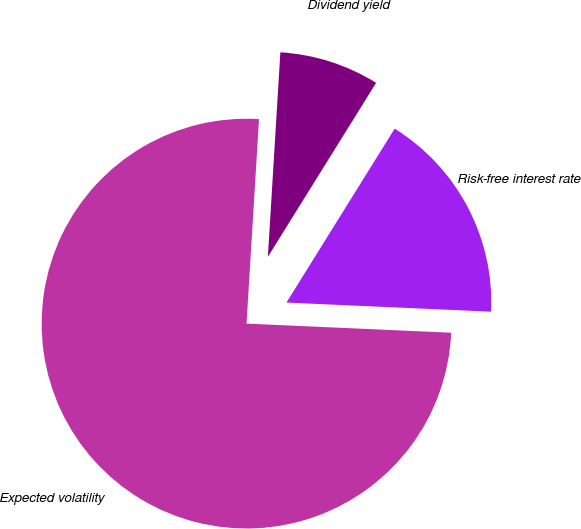Convert chart. <chart><loc_0><loc_0><loc_500><loc_500><pie_chart><fcel>Dividend yield<fcel>Expected volatility<fcel>Risk-free interest rate<nl><fcel>7.89%<fcel>75.27%<fcel>16.85%<nl></chart> 